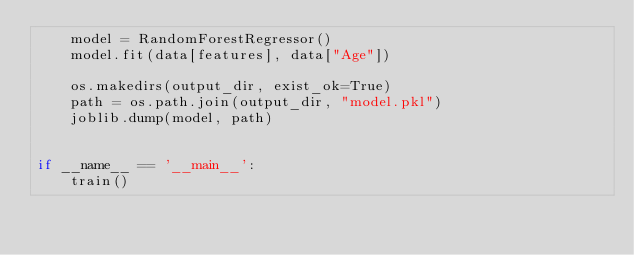<code> <loc_0><loc_0><loc_500><loc_500><_Python_>    model = RandomForestRegressor()
    model.fit(data[features], data["Age"])

    os.makedirs(output_dir, exist_ok=True)
    path = os.path.join(output_dir, "model.pkl")
    joblib.dump(model, path)


if __name__ == '__main__':
    train()
</code> 